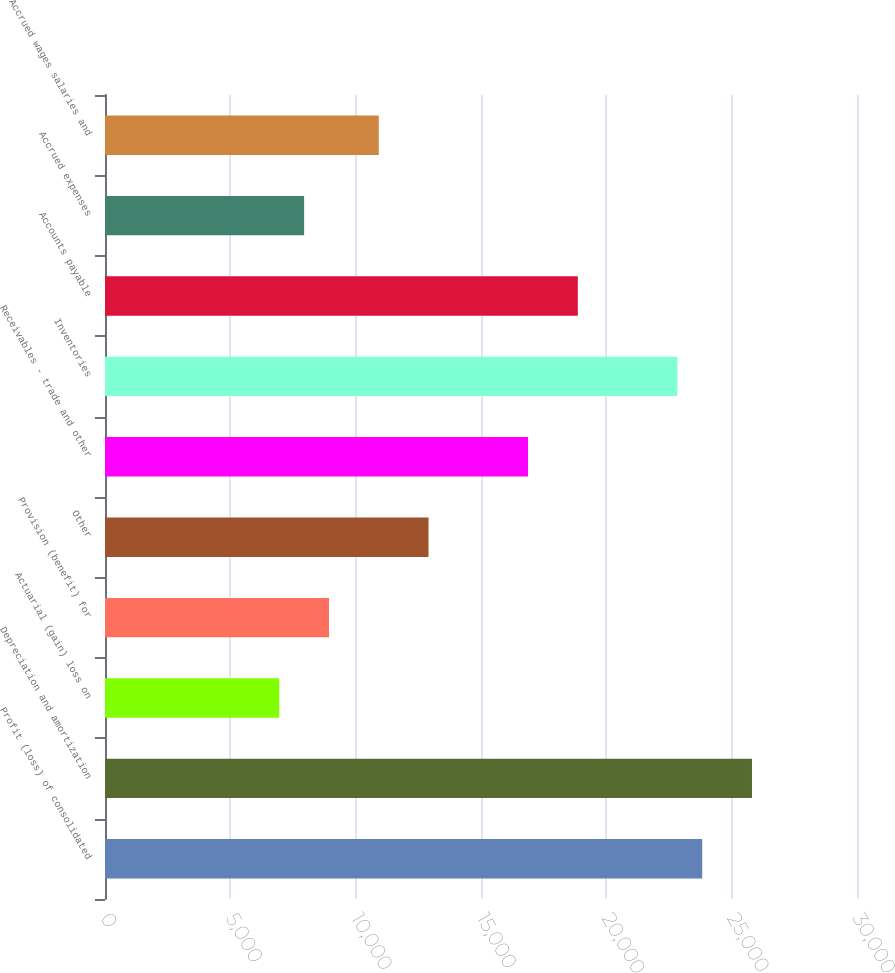<chart> <loc_0><loc_0><loc_500><loc_500><bar_chart><fcel>Profit (loss) of consolidated<fcel>Depreciation and amortization<fcel>Actuarial (gain) loss on<fcel>Provision (benefit) for<fcel>Other<fcel>Receivables - trade and other<fcel>Inventories<fcel>Accounts payable<fcel>Accrued expenses<fcel>Accrued wages salaries and<nl><fcel>23825.4<fcel>25810.6<fcel>6951.2<fcel>8936.4<fcel>12906.8<fcel>16877.2<fcel>22832.8<fcel>18862.4<fcel>7943.8<fcel>10921.6<nl></chart> 